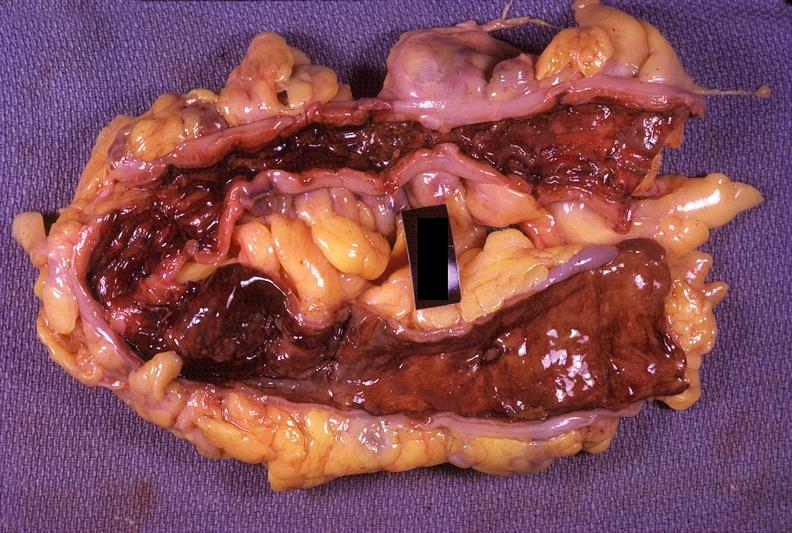does lower chest and abdomen anterior show colon, ulcerative colitis?
Answer the question using a single word or phrase. No 